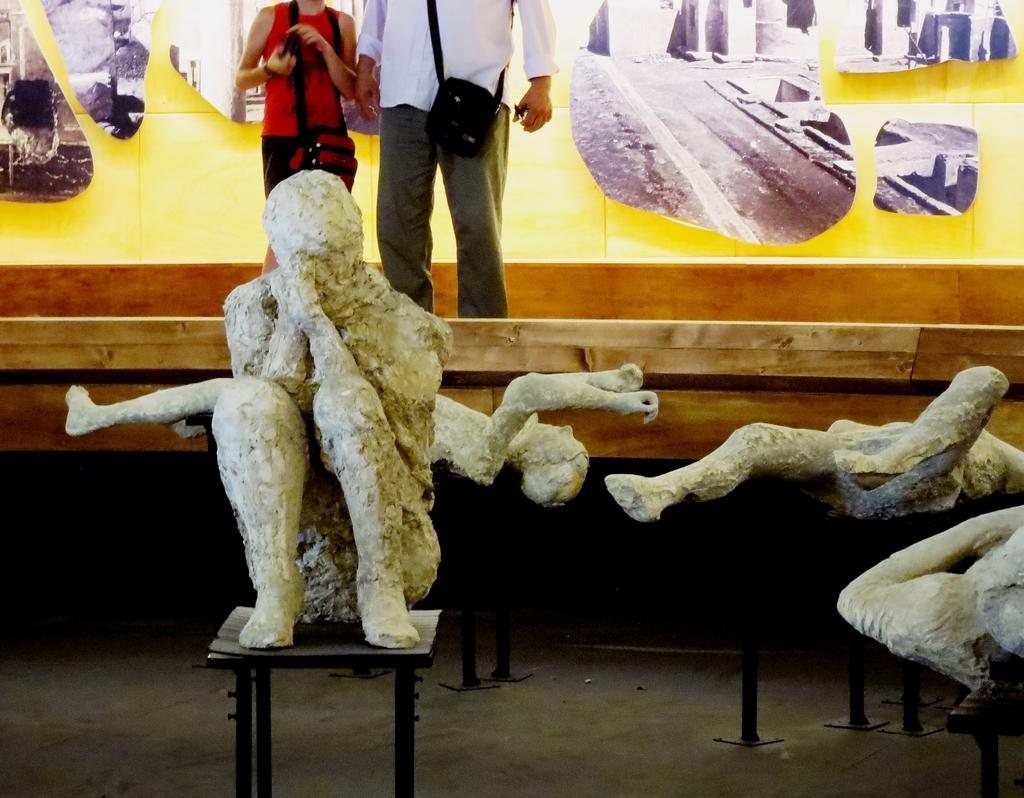What can be seen in the image that represents art or sculpture? There are statues in the image. How many people are present in the image? There are two persons standing in the image. What type of furniture is visible in the image? There are tables in the image. Can you tell me how many planes are flying over the park in the image? There is no park or planes present in the image. The image features statues, two persons, and tables. 